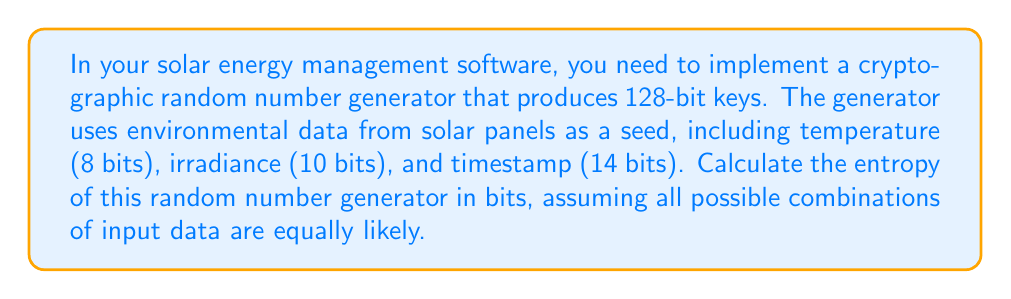Provide a solution to this math problem. To calculate the entropy of the random number generator, we need to follow these steps:

1. Identify the number of possible unique inputs:
   - Temperature: 8 bits = $2^8 = 256$ possibilities
   - Irradiance: 10 bits = $2^{10} = 1,024$ possibilities
   - Timestamp: 14 bits = $2^{14} = 16,384$ possibilities

2. Calculate the total number of possible unique combinations:
   $$ \text{Total combinations} = 256 \times 1,024 \times 16,384 = 2^{32} $$

3. Since all combinations are equally likely, we can use the formula for maximum entropy:
   $$ H = \log_2(N) $$
   where $H$ is the entropy in bits, and $N$ is the number of possible outcomes.

4. Substitute the total number of combinations into the formula:
   $$ H = \log_2(2^{32}) = 32 \text{ bits} $$

Therefore, the entropy of the random number generator is 32 bits.

It's important to note that while the generator produces 128-bit keys, its entropy is limited by its input, which is only 32 bits in this case. This means that the effective security strength of the generated keys is significantly lower than 128 bits, and the system may be vulnerable to attacks.
Answer: 32 bits 